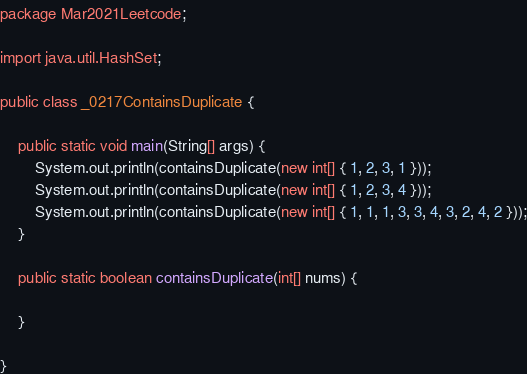<code> <loc_0><loc_0><loc_500><loc_500><_Java_>package Mar2021Leetcode;

import java.util.HashSet;

public class _0217ContainsDuplicate {

	public static void main(String[] args) {
		System.out.println(containsDuplicate(new int[] { 1, 2, 3, 1 }));
		System.out.println(containsDuplicate(new int[] { 1, 2, 3, 4 }));
		System.out.println(containsDuplicate(new int[] { 1, 1, 1, 3, 3, 4, 3, 2, 4, 2 }));
	}

	public static boolean containsDuplicate(int[] nums) {
		
	}

}
</code> 